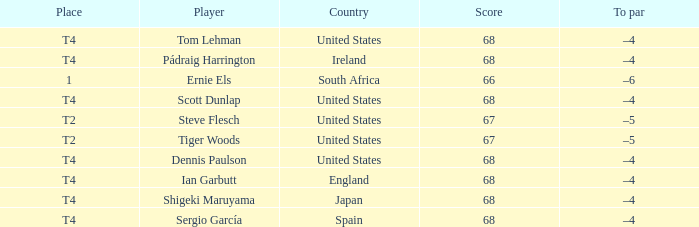What is the Place of the Player with a Score of 67? T2, T2. 